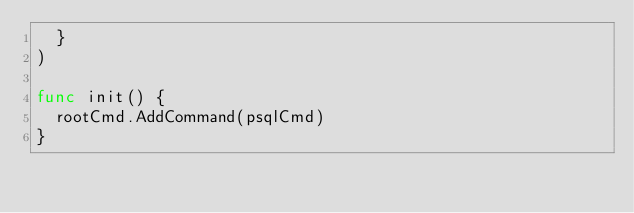<code> <loc_0><loc_0><loc_500><loc_500><_Go_>	}
)

func init() {
	rootCmd.AddCommand(psqlCmd)
}
</code> 